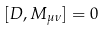Convert formula to latex. <formula><loc_0><loc_0><loc_500><loc_500>[ D , M _ { \mu \nu } ] = 0</formula> 